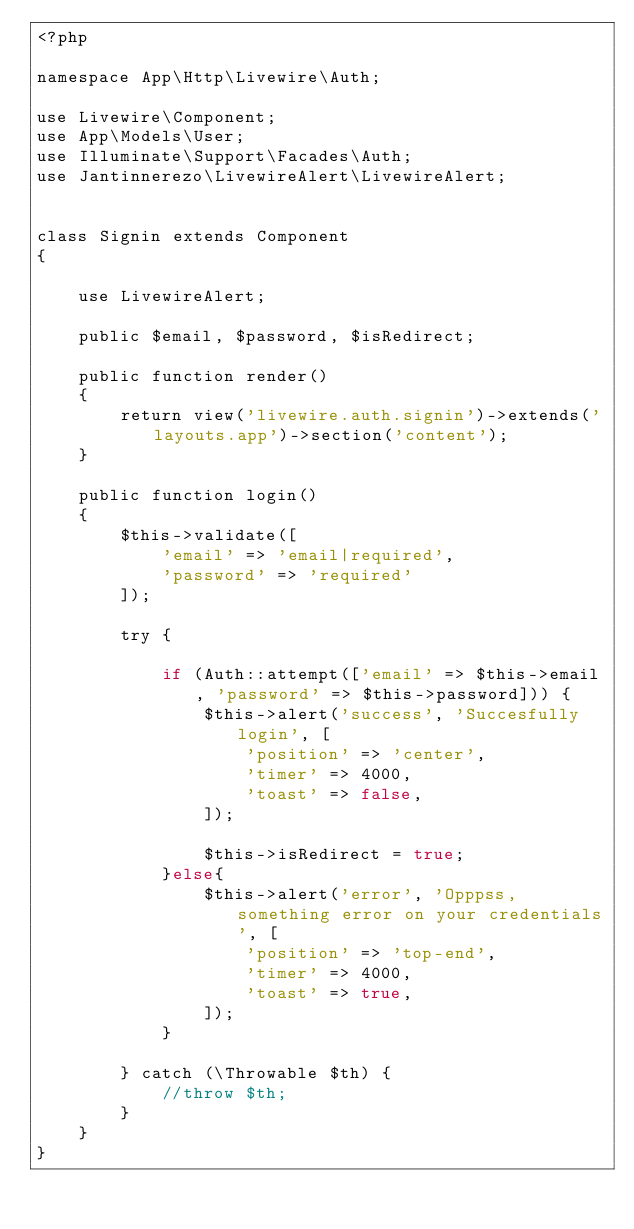<code> <loc_0><loc_0><loc_500><loc_500><_PHP_><?php

namespace App\Http\Livewire\Auth;

use Livewire\Component;
use App\Models\User;
use Illuminate\Support\Facades\Auth;
use Jantinnerezo\LivewireAlert\LivewireAlert;


class Signin extends Component
{

    use LivewireAlert;

    public $email, $password, $isRedirect;

    public function render()
    {
        return view('livewire.auth.signin')->extends('layouts.app')->section('content');
    }

    public function login()
    {
        $this->validate([
            'email' => 'email|required',
            'password' => 'required'
        ]);

        try {

            if (Auth::attempt(['email' => $this->email, 'password' => $this->password])) {
                $this->alert('success', 'Succesfully login', [
                    'position' => 'center',
                    'timer' => 4000,
                    'toast' => false,
                ]);

                $this->isRedirect = true;
            }else{
                $this->alert('error', 'Opppss, something error on your credentials', [
                    'position' => 'top-end',
                    'timer' => 4000,
                    'toast' => true,
                ]);
            }

        } catch (\Throwable $th) {
            //throw $th;
        }
    }
}
</code> 